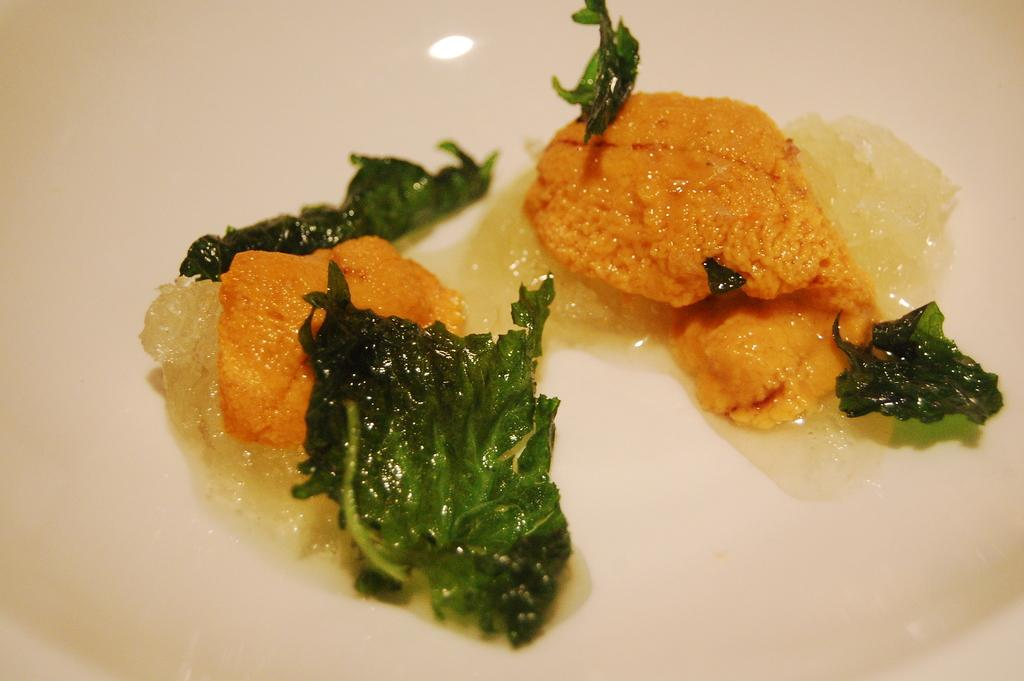What is present on the plate in the image? There are food items in the plate. Can you describe the plate in the image? The plate is visible in the image, but no specific details about its appearance are provided. What time does the clock on the plate indicate in the image? There is no clock present on the plate in the image. 